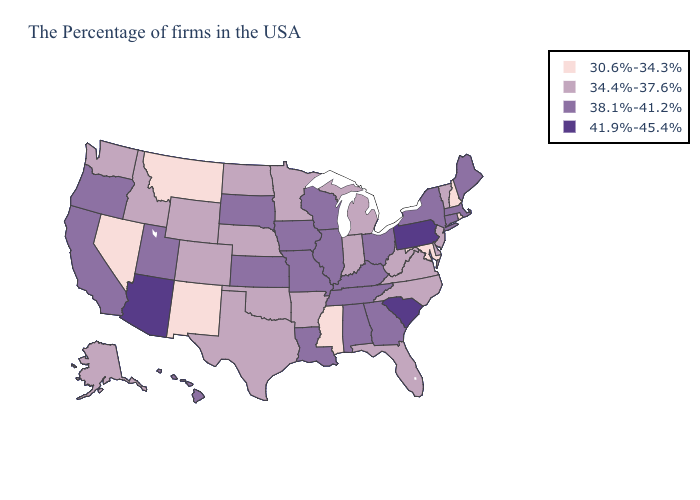Name the states that have a value in the range 41.9%-45.4%?
Write a very short answer. Pennsylvania, South Carolina, Arizona. Which states have the highest value in the USA?
Give a very brief answer. Pennsylvania, South Carolina, Arizona. Does Idaho have the lowest value in the West?
Be succinct. No. Name the states that have a value in the range 30.6%-34.3%?
Be succinct. Rhode Island, New Hampshire, Maryland, Mississippi, New Mexico, Montana, Nevada. Name the states that have a value in the range 34.4%-37.6%?
Quick response, please. Vermont, New Jersey, Delaware, Virginia, North Carolina, West Virginia, Florida, Michigan, Indiana, Arkansas, Minnesota, Nebraska, Oklahoma, Texas, North Dakota, Wyoming, Colorado, Idaho, Washington, Alaska. Name the states that have a value in the range 30.6%-34.3%?
Keep it brief. Rhode Island, New Hampshire, Maryland, Mississippi, New Mexico, Montana, Nevada. Does Arizona have the highest value in the USA?
Keep it brief. Yes. What is the value of Louisiana?
Short answer required. 38.1%-41.2%. Which states hav the highest value in the South?
Keep it brief. South Carolina. Which states have the lowest value in the USA?
Answer briefly. Rhode Island, New Hampshire, Maryland, Mississippi, New Mexico, Montana, Nevada. Name the states that have a value in the range 38.1%-41.2%?
Quick response, please. Maine, Massachusetts, Connecticut, New York, Ohio, Georgia, Kentucky, Alabama, Tennessee, Wisconsin, Illinois, Louisiana, Missouri, Iowa, Kansas, South Dakota, Utah, California, Oregon, Hawaii. Name the states that have a value in the range 30.6%-34.3%?
Answer briefly. Rhode Island, New Hampshire, Maryland, Mississippi, New Mexico, Montana, Nevada. What is the value of Louisiana?
Short answer required. 38.1%-41.2%. Which states have the lowest value in the MidWest?
Give a very brief answer. Michigan, Indiana, Minnesota, Nebraska, North Dakota. Name the states that have a value in the range 41.9%-45.4%?
Quick response, please. Pennsylvania, South Carolina, Arizona. 